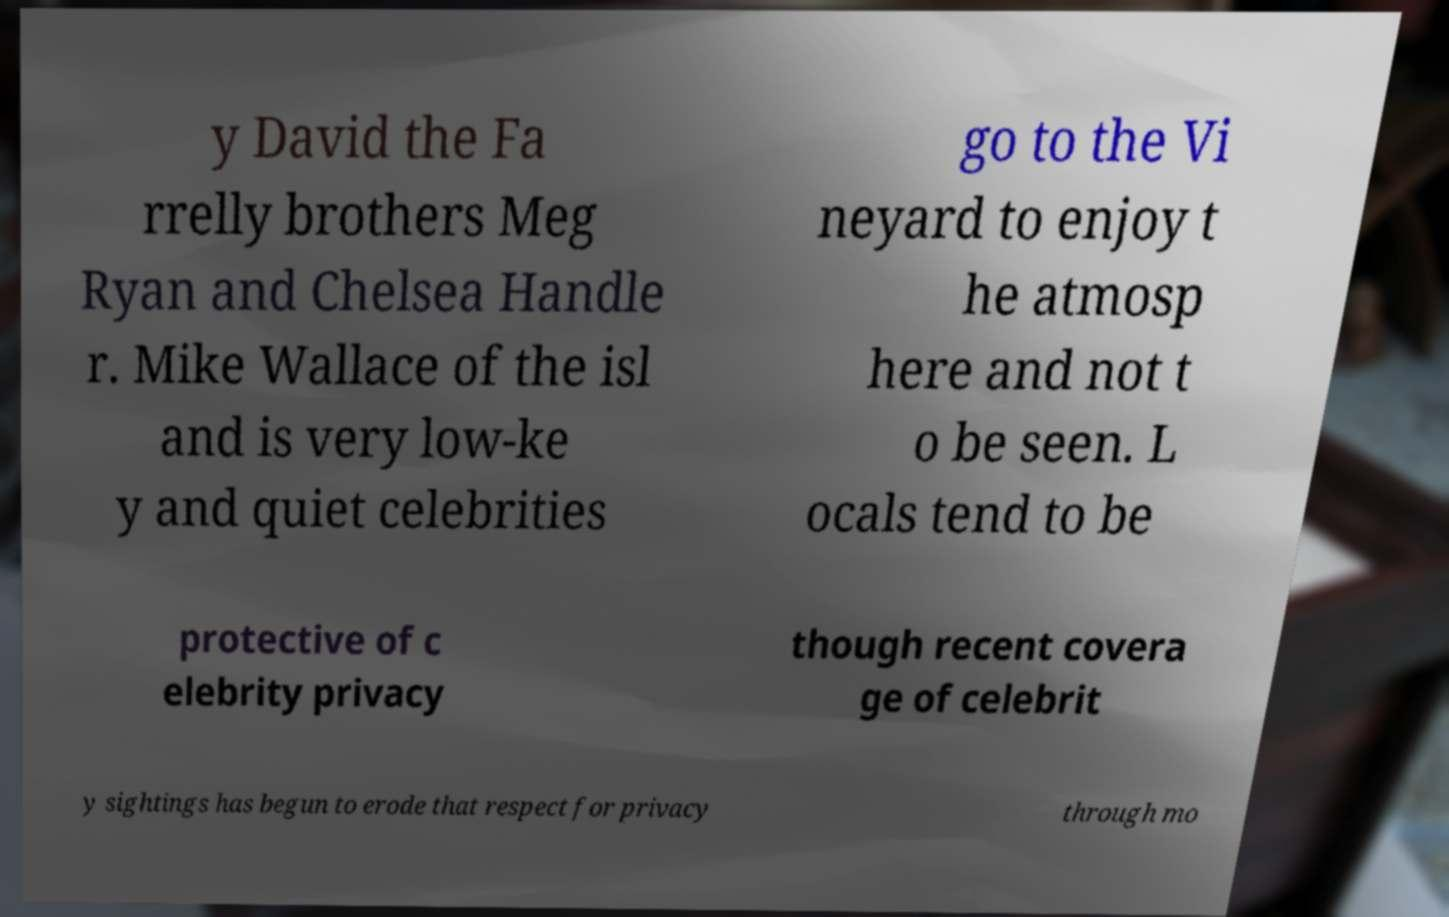Could you assist in decoding the text presented in this image and type it out clearly? y David the Fa rrelly brothers Meg Ryan and Chelsea Handle r. Mike Wallace of the isl and is very low-ke y and quiet celebrities go to the Vi neyard to enjoy t he atmosp here and not t o be seen. L ocals tend to be protective of c elebrity privacy though recent covera ge of celebrit y sightings has begun to erode that respect for privacy through mo 